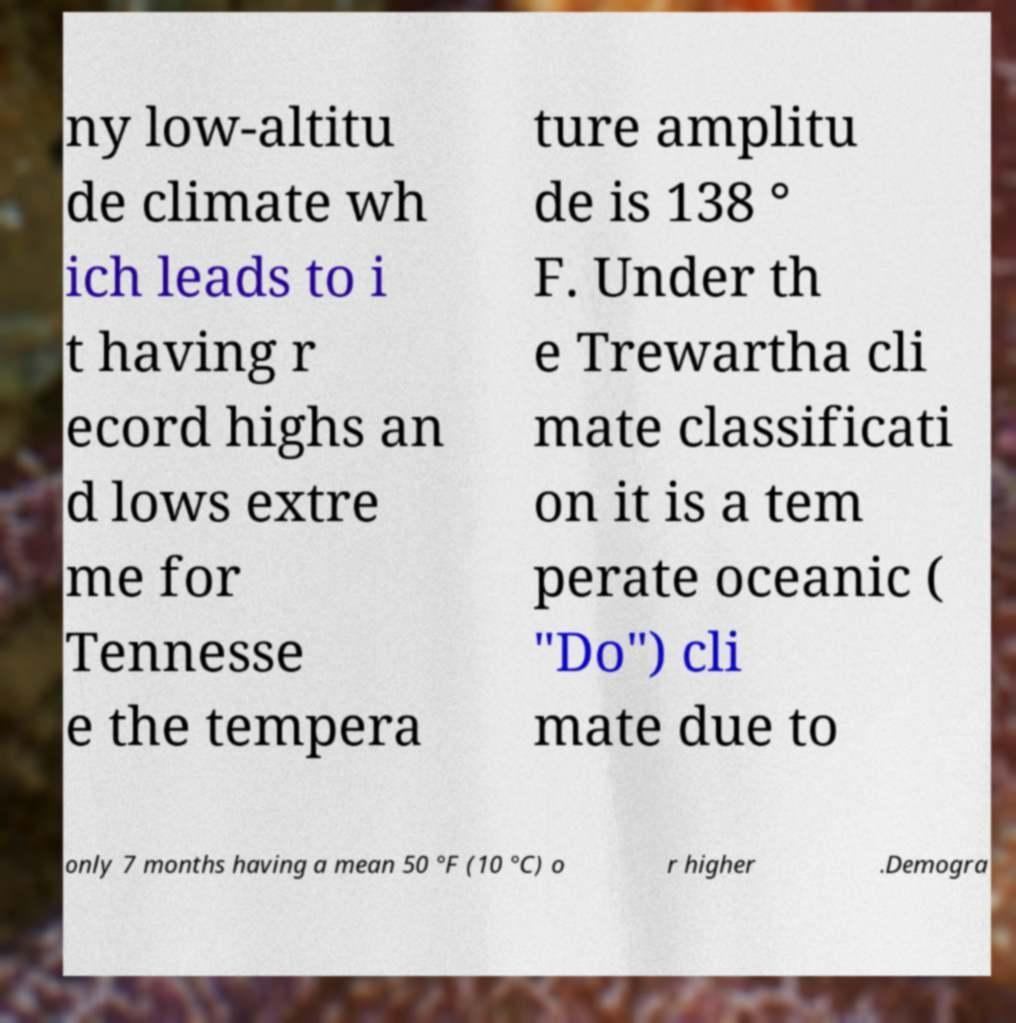Please identify and transcribe the text found in this image. ny low-altitu de climate wh ich leads to i t having r ecord highs an d lows extre me for Tennesse e the tempera ture amplitu de is 138 ° F. Under th e Trewartha cli mate classificati on it is a tem perate oceanic ( "Do") cli mate due to only 7 months having a mean 50 °F (10 °C) o r higher .Demogra 